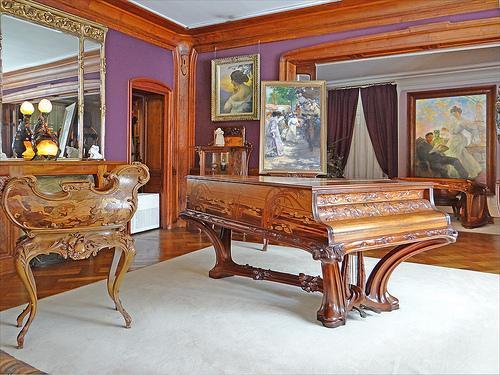How many windows are visible in the photo?
Give a very brief answer. 1. 